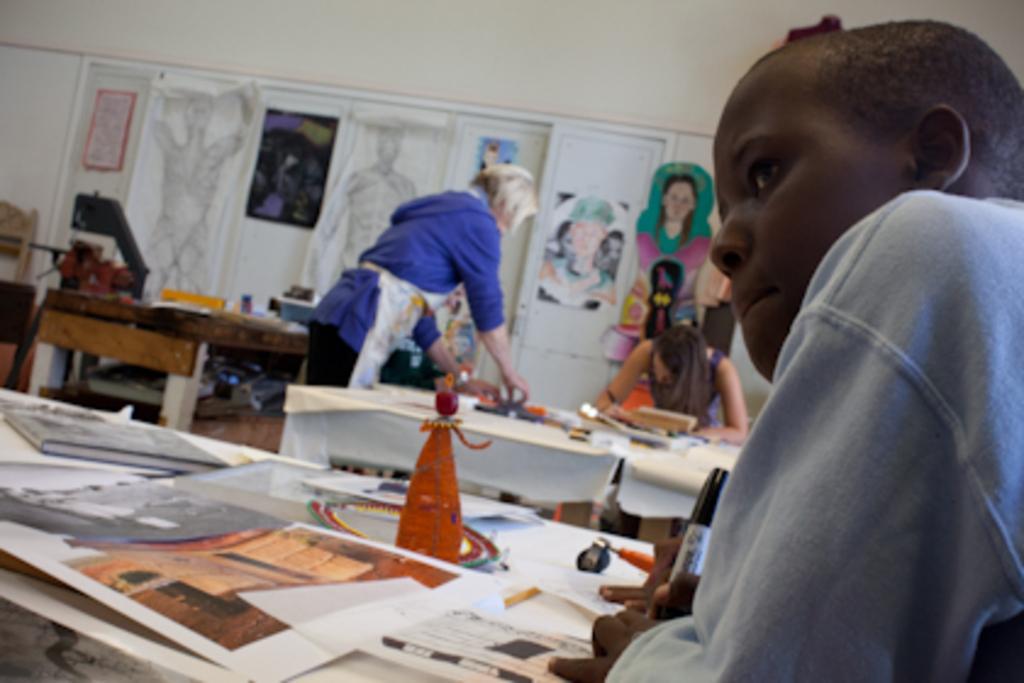In one or two sentences, can you explain what this image depicts? In this image I see 3 persons, in which 2 of them are female and one of them is a male and I can also see there are 3 tables and lot of papers on it. In the background I can see the wall and few pictures on it. 